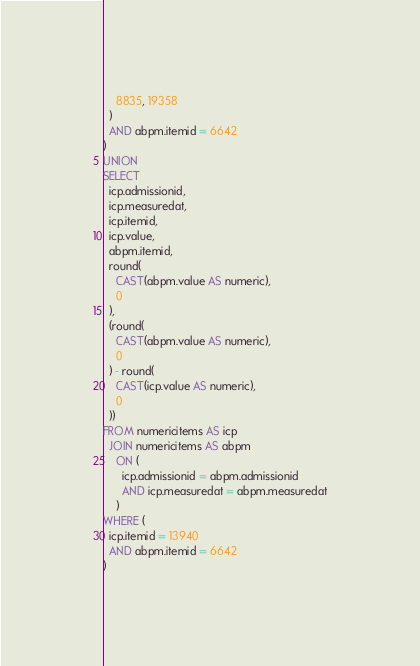Convert code to text. <code><loc_0><loc_0><loc_500><loc_500><_SQL_>    8835, 19358
  )
  AND abpm.itemid = 6642
)
UNION
SELECT
  icp.admissionid,
  icp.measuredat,
  icp.itemid,
  icp.value,
  abpm.itemid,
  round(
    CAST(abpm.value AS numeric),
    0
  ),
  (round(
    CAST(abpm.value AS numeric),
    0
  ) - round(
    CAST(icp.value AS numeric),
    0
  ))
FROM numericitems AS icp
  JOIN numericitems AS abpm
    ON (
      icp.admissionid = abpm.admissionid
      AND icp.measuredat = abpm.measuredat
    )
WHERE (
  icp.itemid = 13940
  AND abpm.itemid = 6642
)</code> 